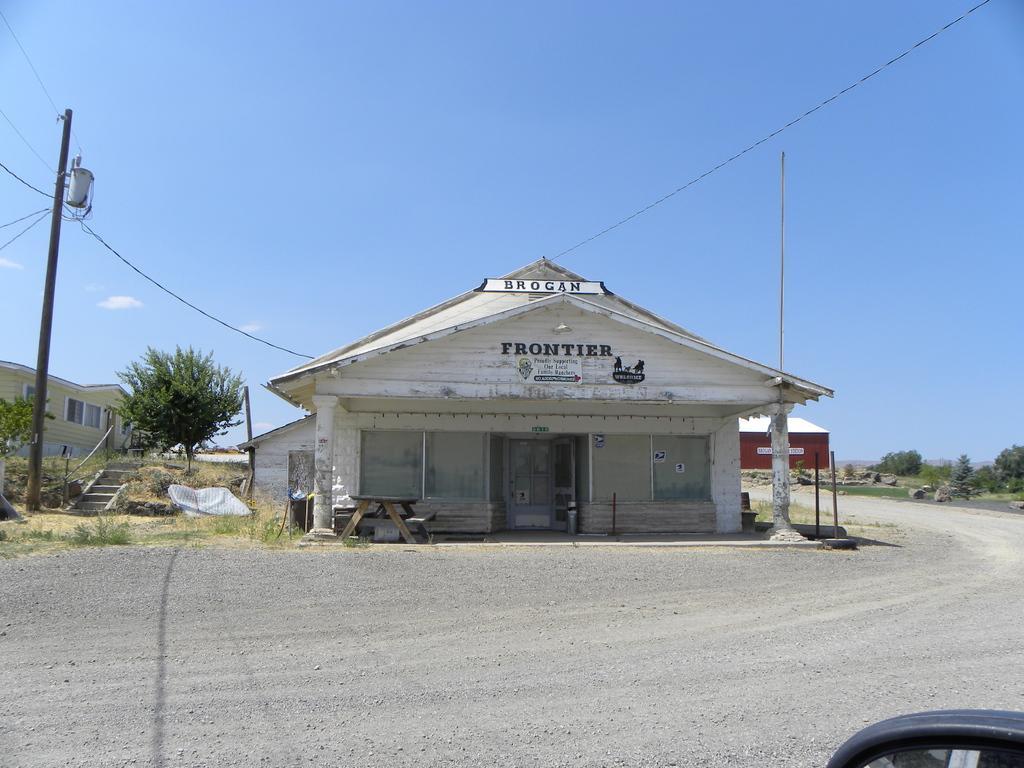Describe this image in one or two sentences. In this picture I can see there is a road, house, trees and pole with cables and the sky is clear. 